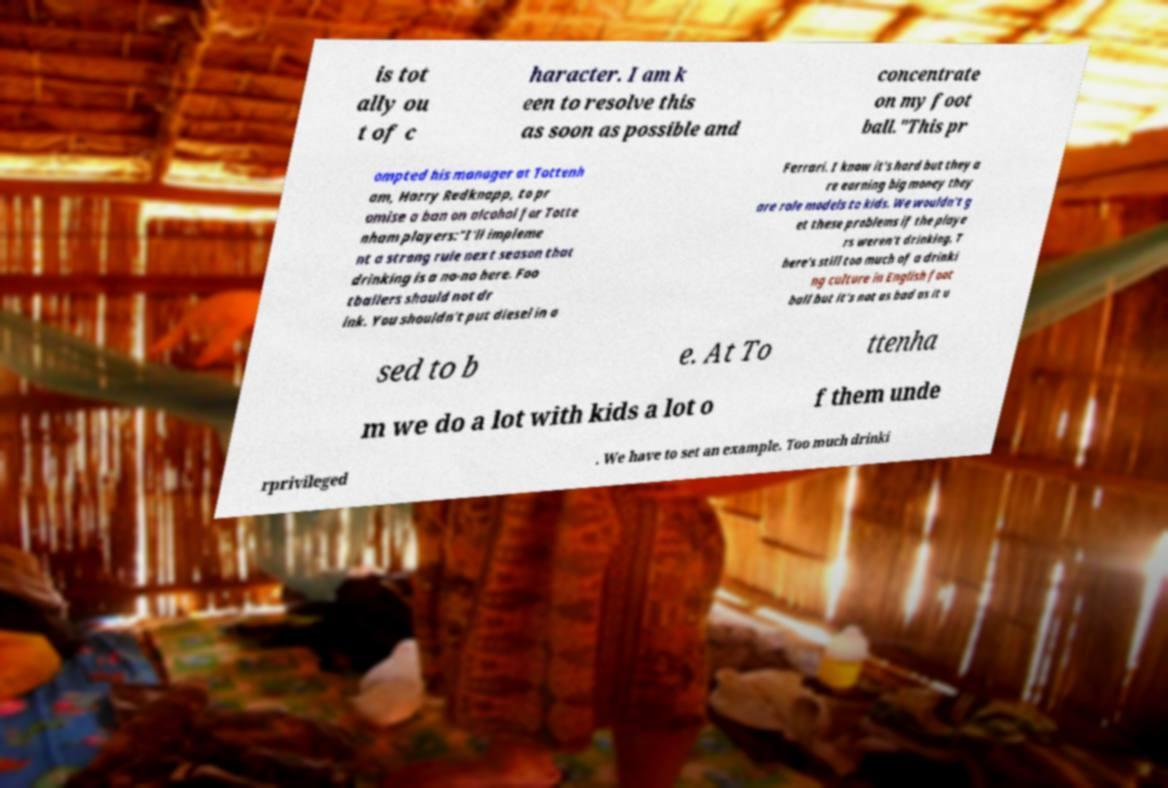For documentation purposes, I need the text within this image transcribed. Could you provide that? is tot ally ou t of c haracter. I am k een to resolve this as soon as possible and concentrate on my foot ball."This pr ompted his manager at Tottenh am, Harry Redknapp, to pr omise a ban on alcohol for Totte nham players:"I'll impleme nt a strong rule next season that drinking is a no-no here. Foo tballers should not dr ink. You shouldn't put diesel in a Ferrari. I know it's hard but they a re earning big money they are role models to kids. We wouldn't g et these problems if the playe rs weren't drinking. T here's still too much of a drinki ng culture in English foot ball but it's not as bad as it u sed to b e. At To ttenha m we do a lot with kids a lot o f them unde rprivileged . We have to set an example. Too much drinki 